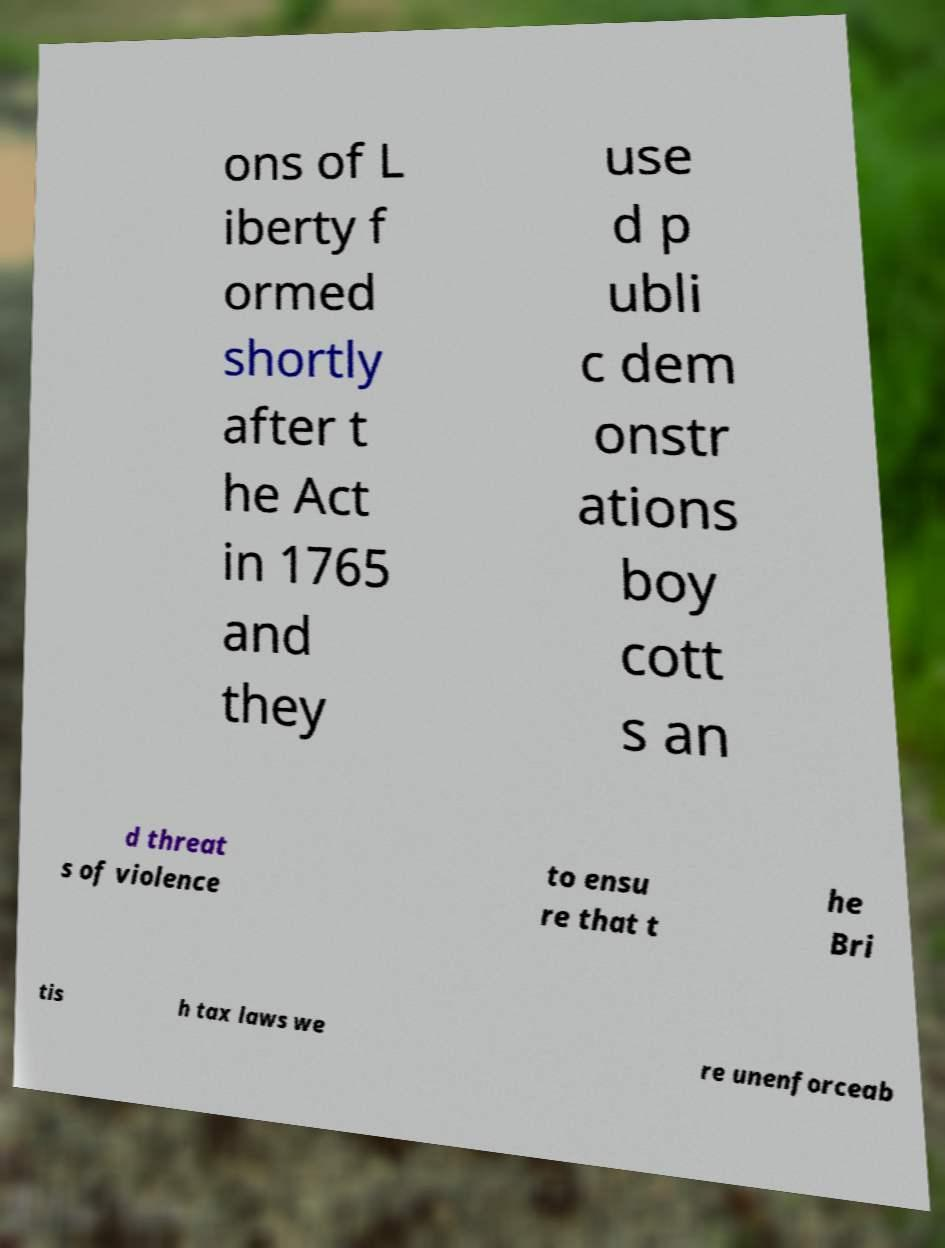Please identify and transcribe the text found in this image. ons of L iberty f ormed shortly after t he Act in 1765 and they use d p ubli c dem onstr ations boy cott s an d threat s of violence to ensu re that t he Bri tis h tax laws we re unenforceab 